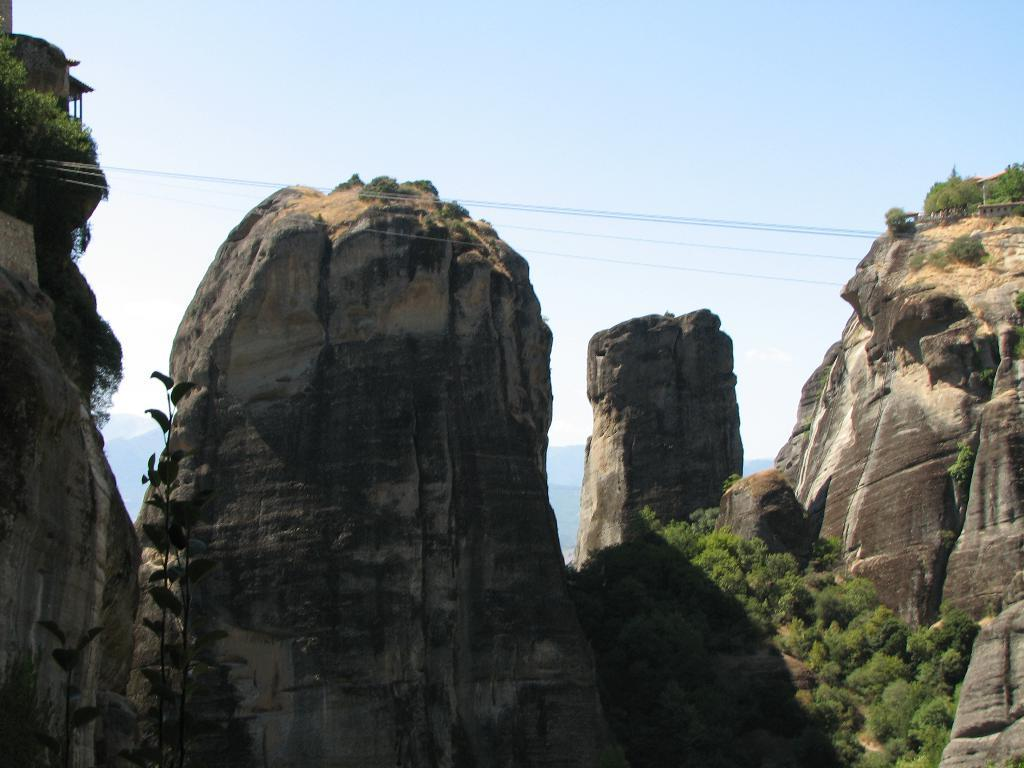What type of geological formation can be seen in the image? There are rock mountains in the image. What else can be seen in the image besides the rock mountains? There are wires, trees, and plants visible in the image. What is the condition of the sky in the image? The sky is clear and visible in the background of the image? Is there any snow visible on the rock mountains in the image? There is no snow present in the image; the sky is clear and visible in the background. 